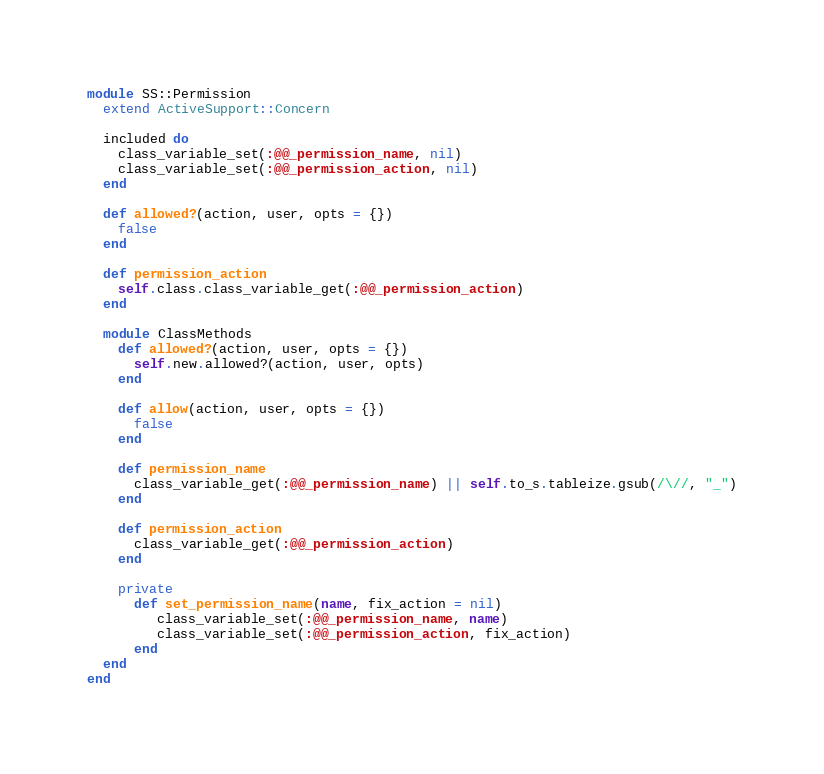<code> <loc_0><loc_0><loc_500><loc_500><_Ruby_>module SS::Permission
  extend ActiveSupport::Concern

  included do
    class_variable_set(:@@_permission_name, nil)
    class_variable_set(:@@_permission_action, nil)
  end

  def allowed?(action, user, opts = {})
    false
  end

  def permission_action
    self.class.class_variable_get(:@@_permission_action)
  end

  module ClassMethods
    def allowed?(action, user, opts = {})
      self.new.allowed?(action, user, opts)
    end

    def allow(action, user, opts = {})
      false
    end

    def permission_name
      class_variable_get(:@@_permission_name) || self.to_s.tableize.gsub(/\//, "_")
    end

    def permission_action
      class_variable_get(:@@_permission_action)
    end

    private
      def set_permission_name(name, fix_action = nil)
         class_variable_set(:@@_permission_name, name)
         class_variable_set(:@@_permission_action, fix_action)
      end
  end
end
</code> 